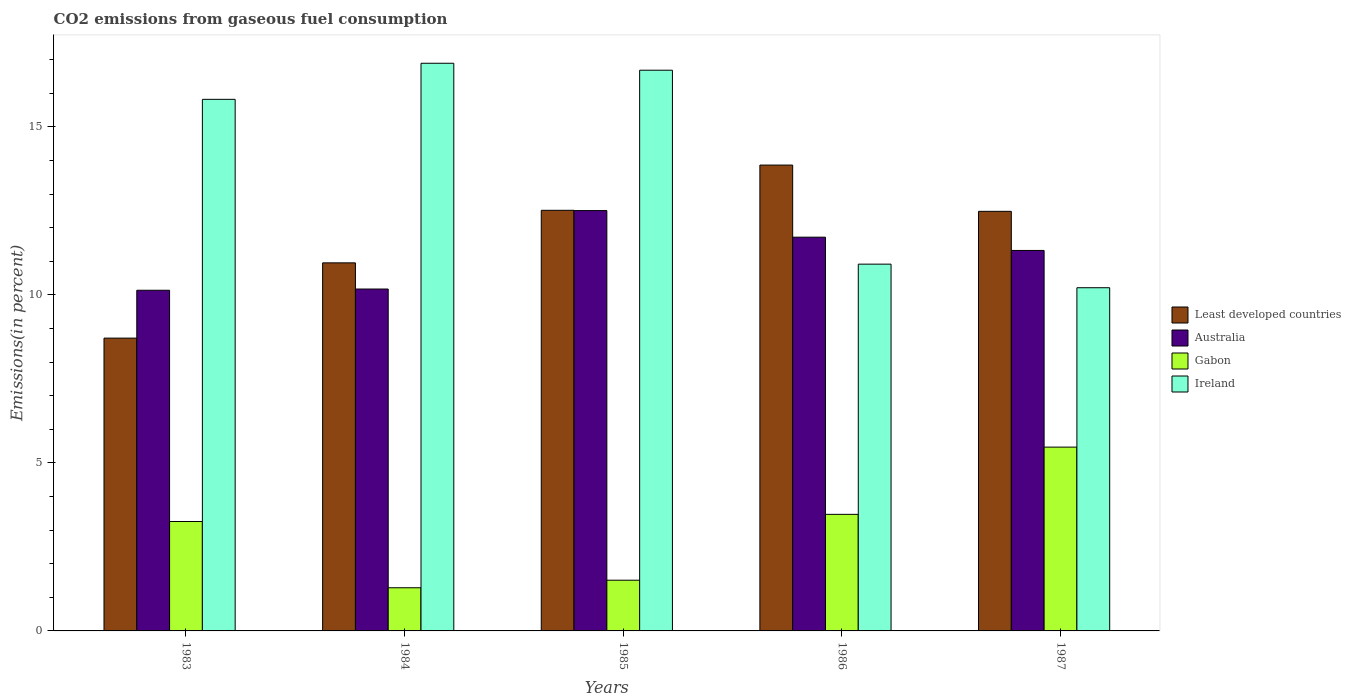How many different coloured bars are there?
Give a very brief answer. 4. Are the number of bars per tick equal to the number of legend labels?
Offer a terse response. Yes. How many bars are there on the 3rd tick from the right?
Provide a succinct answer. 4. What is the label of the 3rd group of bars from the left?
Give a very brief answer. 1985. In how many cases, is the number of bars for a given year not equal to the number of legend labels?
Make the answer very short. 0. What is the total CO2 emitted in Gabon in 1985?
Offer a very short reply. 1.51. Across all years, what is the maximum total CO2 emitted in Ireland?
Give a very brief answer. 16.89. Across all years, what is the minimum total CO2 emitted in Australia?
Keep it short and to the point. 10.14. In which year was the total CO2 emitted in Gabon minimum?
Provide a short and direct response. 1984. What is the total total CO2 emitted in Gabon in the graph?
Your answer should be very brief. 14.99. What is the difference between the total CO2 emitted in Ireland in 1983 and that in 1987?
Your answer should be compact. 5.61. What is the difference between the total CO2 emitted in Gabon in 1983 and the total CO2 emitted in Ireland in 1984?
Offer a very short reply. -13.64. What is the average total CO2 emitted in Least developed countries per year?
Your answer should be compact. 11.71. In the year 1984, what is the difference between the total CO2 emitted in Gabon and total CO2 emitted in Australia?
Your answer should be compact. -8.89. What is the ratio of the total CO2 emitted in Australia in 1983 to that in 1986?
Your response must be concise. 0.87. Is the difference between the total CO2 emitted in Gabon in 1983 and 1984 greater than the difference between the total CO2 emitted in Australia in 1983 and 1984?
Your response must be concise. Yes. What is the difference between the highest and the second highest total CO2 emitted in Gabon?
Offer a terse response. 2. What is the difference between the highest and the lowest total CO2 emitted in Least developed countries?
Give a very brief answer. 5.15. Is the sum of the total CO2 emitted in Australia in 1984 and 1985 greater than the maximum total CO2 emitted in Least developed countries across all years?
Offer a very short reply. Yes. Is it the case that in every year, the sum of the total CO2 emitted in Least developed countries and total CO2 emitted in Gabon is greater than the sum of total CO2 emitted in Australia and total CO2 emitted in Ireland?
Give a very brief answer. No. What does the 4th bar from the left in 1985 represents?
Offer a terse response. Ireland. What does the 4th bar from the right in 1984 represents?
Keep it short and to the point. Least developed countries. How many years are there in the graph?
Offer a very short reply. 5. What is the difference between two consecutive major ticks on the Y-axis?
Provide a short and direct response. 5. Are the values on the major ticks of Y-axis written in scientific E-notation?
Your response must be concise. No. Where does the legend appear in the graph?
Offer a terse response. Center right. How many legend labels are there?
Keep it short and to the point. 4. What is the title of the graph?
Your response must be concise. CO2 emissions from gaseous fuel consumption. Does "New Zealand" appear as one of the legend labels in the graph?
Offer a terse response. No. What is the label or title of the Y-axis?
Offer a terse response. Emissions(in percent). What is the Emissions(in percent) in Least developed countries in 1983?
Your response must be concise. 8.71. What is the Emissions(in percent) in Australia in 1983?
Your answer should be compact. 10.14. What is the Emissions(in percent) in Gabon in 1983?
Your response must be concise. 3.26. What is the Emissions(in percent) of Ireland in 1983?
Give a very brief answer. 15.82. What is the Emissions(in percent) of Least developed countries in 1984?
Provide a short and direct response. 10.95. What is the Emissions(in percent) in Australia in 1984?
Your answer should be very brief. 10.17. What is the Emissions(in percent) of Gabon in 1984?
Give a very brief answer. 1.28. What is the Emissions(in percent) in Ireland in 1984?
Keep it short and to the point. 16.89. What is the Emissions(in percent) of Least developed countries in 1985?
Keep it short and to the point. 12.52. What is the Emissions(in percent) in Australia in 1985?
Ensure brevity in your answer.  12.51. What is the Emissions(in percent) of Gabon in 1985?
Your answer should be compact. 1.51. What is the Emissions(in percent) of Ireland in 1985?
Your answer should be compact. 16.68. What is the Emissions(in percent) of Least developed countries in 1986?
Offer a terse response. 13.86. What is the Emissions(in percent) in Australia in 1986?
Your answer should be very brief. 11.72. What is the Emissions(in percent) in Gabon in 1986?
Provide a short and direct response. 3.47. What is the Emissions(in percent) of Ireland in 1986?
Give a very brief answer. 10.91. What is the Emissions(in percent) in Least developed countries in 1987?
Your response must be concise. 12.49. What is the Emissions(in percent) of Australia in 1987?
Provide a short and direct response. 11.32. What is the Emissions(in percent) in Gabon in 1987?
Provide a succinct answer. 5.47. What is the Emissions(in percent) in Ireland in 1987?
Provide a short and direct response. 10.21. Across all years, what is the maximum Emissions(in percent) in Least developed countries?
Provide a short and direct response. 13.86. Across all years, what is the maximum Emissions(in percent) of Australia?
Provide a succinct answer. 12.51. Across all years, what is the maximum Emissions(in percent) in Gabon?
Offer a very short reply. 5.47. Across all years, what is the maximum Emissions(in percent) of Ireland?
Provide a succinct answer. 16.89. Across all years, what is the minimum Emissions(in percent) of Least developed countries?
Provide a succinct answer. 8.71. Across all years, what is the minimum Emissions(in percent) of Australia?
Provide a short and direct response. 10.14. Across all years, what is the minimum Emissions(in percent) of Gabon?
Provide a succinct answer. 1.28. Across all years, what is the minimum Emissions(in percent) of Ireland?
Your response must be concise. 10.21. What is the total Emissions(in percent) in Least developed countries in the graph?
Ensure brevity in your answer.  58.53. What is the total Emissions(in percent) of Australia in the graph?
Keep it short and to the point. 55.86. What is the total Emissions(in percent) of Gabon in the graph?
Make the answer very short. 14.99. What is the total Emissions(in percent) of Ireland in the graph?
Offer a terse response. 70.52. What is the difference between the Emissions(in percent) of Least developed countries in 1983 and that in 1984?
Ensure brevity in your answer.  -2.24. What is the difference between the Emissions(in percent) of Australia in 1983 and that in 1984?
Provide a succinct answer. -0.04. What is the difference between the Emissions(in percent) of Gabon in 1983 and that in 1984?
Offer a terse response. 1.97. What is the difference between the Emissions(in percent) in Ireland in 1983 and that in 1984?
Offer a terse response. -1.07. What is the difference between the Emissions(in percent) in Least developed countries in 1983 and that in 1985?
Provide a succinct answer. -3.8. What is the difference between the Emissions(in percent) of Australia in 1983 and that in 1985?
Make the answer very short. -2.37. What is the difference between the Emissions(in percent) of Gabon in 1983 and that in 1985?
Your answer should be compact. 1.75. What is the difference between the Emissions(in percent) of Ireland in 1983 and that in 1985?
Provide a short and direct response. -0.87. What is the difference between the Emissions(in percent) in Least developed countries in 1983 and that in 1986?
Ensure brevity in your answer.  -5.15. What is the difference between the Emissions(in percent) in Australia in 1983 and that in 1986?
Keep it short and to the point. -1.58. What is the difference between the Emissions(in percent) in Gabon in 1983 and that in 1986?
Offer a very short reply. -0.21. What is the difference between the Emissions(in percent) of Ireland in 1983 and that in 1986?
Your answer should be compact. 4.9. What is the difference between the Emissions(in percent) of Least developed countries in 1983 and that in 1987?
Offer a very short reply. -3.77. What is the difference between the Emissions(in percent) of Australia in 1983 and that in 1987?
Offer a terse response. -1.18. What is the difference between the Emissions(in percent) in Gabon in 1983 and that in 1987?
Your answer should be very brief. -2.21. What is the difference between the Emissions(in percent) of Ireland in 1983 and that in 1987?
Offer a terse response. 5.61. What is the difference between the Emissions(in percent) of Least developed countries in 1984 and that in 1985?
Make the answer very short. -1.56. What is the difference between the Emissions(in percent) in Australia in 1984 and that in 1985?
Keep it short and to the point. -2.33. What is the difference between the Emissions(in percent) of Gabon in 1984 and that in 1985?
Provide a succinct answer. -0.22. What is the difference between the Emissions(in percent) in Ireland in 1984 and that in 1985?
Your answer should be very brief. 0.21. What is the difference between the Emissions(in percent) in Least developed countries in 1984 and that in 1986?
Your response must be concise. -2.91. What is the difference between the Emissions(in percent) in Australia in 1984 and that in 1986?
Provide a succinct answer. -1.54. What is the difference between the Emissions(in percent) in Gabon in 1984 and that in 1986?
Offer a terse response. -2.18. What is the difference between the Emissions(in percent) of Ireland in 1984 and that in 1986?
Ensure brevity in your answer.  5.98. What is the difference between the Emissions(in percent) in Least developed countries in 1984 and that in 1987?
Provide a short and direct response. -1.53. What is the difference between the Emissions(in percent) of Australia in 1984 and that in 1987?
Your response must be concise. -1.15. What is the difference between the Emissions(in percent) in Gabon in 1984 and that in 1987?
Your answer should be very brief. -4.19. What is the difference between the Emissions(in percent) in Ireland in 1984 and that in 1987?
Provide a succinct answer. 6.68. What is the difference between the Emissions(in percent) in Least developed countries in 1985 and that in 1986?
Your response must be concise. -1.35. What is the difference between the Emissions(in percent) of Australia in 1985 and that in 1986?
Provide a short and direct response. 0.79. What is the difference between the Emissions(in percent) of Gabon in 1985 and that in 1986?
Offer a terse response. -1.96. What is the difference between the Emissions(in percent) in Ireland in 1985 and that in 1986?
Make the answer very short. 5.77. What is the difference between the Emissions(in percent) of Least developed countries in 1985 and that in 1987?
Provide a short and direct response. 0.03. What is the difference between the Emissions(in percent) of Australia in 1985 and that in 1987?
Your answer should be compact. 1.19. What is the difference between the Emissions(in percent) of Gabon in 1985 and that in 1987?
Your answer should be compact. -3.96. What is the difference between the Emissions(in percent) in Ireland in 1985 and that in 1987?
Your answer should be very brief. 6.47. What is the difference between the Emissions(in percent) in Least developed countries in 1986 and that in 1987?
Your answer should be very brief. 1.38. What is the difference between the Emissions(in percent) in Australia in 1986 and that in 1987?
Your response must be concise. 0.39. What is the difference between the Emissions(in percent) in Gabon in 1986 and that in 1987?
Give a very brief answer. -2. What is the difference between the Emissions(in percent) of Ireland in 1986 and that in 1987?
Your response must be concise. 0.7. What is the difference between the Emissions(in percent) of Least developed countries in 1983 and the Emissions(in percent) of Australia in 1984?
Make the answer very short. -1.46. What is the difference between the Emissions(in percent) of Least developed countries in 1983 and the Emissions(in percent) of Gabon in 1984?
Provide a succinct answer. 7.43. What is the difference between the Emissions(in percent) in Least developed countries in 1983 and the Emissions(in percent) in Ireland in 1984?
Give a very brief answer. -8.18. What is the difference between the Emissions(in percent) in Australia in 1983 and the Emissions(in percent) in Gabon in 1984?
Your response must be concise. 8.85. What is the difference between the Emissions(in percent) of Australia in 1983 and the Emissions(in percent) of Ireland in 1984?
Offer a very short reply. -6.75. What is the difference between the Emissions(in percent) in Gabon in 1983 and the Emissions(in percent) in Ireland in 1984?
Keep it short and to the point. -13.64. What is the difference between the Emissions(in percent) in Least developed countries in 1983 and the Emissions(in percent) in Australia in 1985?
Give a very brief answer. -3.79. What is the difference between the Emissions(in percent) in Least developed countries in 1983 and the Emissions(in percent) in Gabon in 1985?
Ensure brevity in your answer.  7.2. What is the difference between the Emissions(in percent) in Least developed countries in 1983 and the Emissions(in percent) in Ireland in 1985?
Provide a short and direct response. -7.97. What is the difference between the Emissions(in percent) of Australia in 1983 and the Emissions(in percent) of Gabon in 1985?
Your answer should be very brief. 8.63. What is the difference between the Emissions(in percent) of Australia in 1983 and the Emissions(in percent) of Ireland in 1985?
Give a very brief answer. -6.55. What is the difference between the Emissions(in percent) of Gabon in 1983 and the Emissions(in percent) of Ireland in 1985?
Ensure brevity in your answer.  -13.43. What is the difference between the Emissions(in percent) in Least developed countries in 1983 and the Emissions(in percent) in Australia in 1986?
Offer a very short reply. -3. What is the difference between the Emissions(in percent) of Least developed countries in 1983 and the Emissions(in percent) of Gabon in 1986?
Keep it short and to the point. 5.24. What is the difference between the Emissions(in percent) of Least developed countries in 1983 and the Emissions(in percent) of Ireland in 1986?
Your answer should be very brief. -2.2. What is the difference between the Emissions(in percent) of Australia in 1983 and the Emissions(in percent) of Gabon in 1986?
Offer a terse response. 6.67. What is the difference between the Emissions(in percent) in Australia in 1983 and the Emissions(in percent) in Ireland in 1986?
Make the answer very short. -0.78. What is the difference between the Emissions(in percent) of Gabon in 1983 and the Emissions(in percent) of Ireland in 1986?
Your answer should be very brief. -7.66. What is the difference between the Emissions(in percent) of Least developed countries in 1983 and the Emissions(in percent) of Australia in 1987?
Make the answer very short. -2.61. What is the difference between the Emissions(in percent) in Least developed countries in 1983 and the Emissions(in percent) in Gabon in 1987?
Ensure brevity in your answer.  3.24. What is the difference between the Emissions(in percent) of Least developed countries in 1983 and the Emissions(in percent) of Ireland in 1987?
Provide a succinct answer. -1.5. What is the difference between the Emissions(in percent) in Australia in 1983 and the Emissions(in percent) in Gabon in 1987?
Give a very brief answer. 4.67. What is the difference between the Emissions(in percent) of Australia in 1983 and the Emissions(in percent) of Ireland in 1987?
Your answer should be compact. -0.08. What is the difference between the Emissions(in percent) in Gabon in 1983 and the Emissions(in percent) in Ireland in 1987?
Provide a short and direct response. -6.96. What is the difference between the Emissions(in percent) of Least developed countries in 1984 and the Emissions(in percent) of Australia in 1985?
Your answer should be compact. -1.56. What is the difference between the Emissions(in percent) in Least developed countries in 1984 and the Emissions(in percent) in Gabon in 1985?
Give a very brief answer. 9.44. What is the difference between the Emissions(in percent) of Least developed countries in 1984 and the Emissions(in percent) of Ireland in 1985?
Keep it short and to the point. -5.73. What is the difference between the Emissions(in percent) of Australia in 1984 and the Emissions(in percent) of Gabon in 1985?
Your answer should be compact. 8.66. What is the difference between the Emissions(in percent) in Australia in 1984 and the Emissions(in percent) in Ireland in 1985?
Your answer should be compact. -6.51. What is the difference between the Emissions(in percent) in Gabon in 1984 and the Emissions(in percent) in Ireland in 1985?
Provide a succinct answer. -15.4. What is the difference between the Emissions(in percent) in Least developed countries in 1984 and the Emissions(in percent) in Australia in 1986?
Ensure brevity in your answer.  -0.76. What is the difference between the Emissions(in percent) of Least developed countries in 1984 and the Emissions(in percent) of Gabon in 1986?
Offer a very short reply. 7.48. What is the difference between the Emissions(in percent) of Least developed countries in 1984 and the Emissions(in percent) of Ireland in 1986?
Provide a short and direct response. 0.04. What is the difference between the Emissions(in percent) in Australia in 1984 and the Emissions(in percent) in Gabon in 1986?
Your response must be concise. 6.71. What is the difference between the Emissions(in percent) of Australia in 1984 and the Emissions(in percent) of Ireland in 1986?
Offer a very short reply. -0.74. What is the difference between the Emissions(in percent) of Gabon in 1984 and the Emissions(in percent) of Ireland in 1986?
Your response must be concise. -9.63. What is the difference between the Emissions(in percent) in Least developed countries in 1984 and the Emissions(in percent) in Australia in 1987?
Make the answer very short. -0.37. What is the difference between the Emissions(in percent) of Least developed countries in 1984 and the Emissions(in percent) of Gabon in 1987?
Keep it short and to the point. 5.48. What is the difference between the Emissions(in percent) of Least developed countries in 1984 and the Emissions(in percent) of Ireland in 1987?
Offer a very short reply. 0.74. What is the difference between the Emissions(in percent) in Australia in 1984 and the Emissions(in percent) in Gabon in 1987?
Offer a very short reply. 4.7. What is the difference between the Emissions(in percent) in Australia in 1984 and the Emissions(in percent) in Ireland in 1987?
Offer a very short reply. -0.04. What is the difference between the Emissions(in percent) of Gabon in 1984 and the Emissions(in percent) of Ireland in 1987?
Give a very brief answer. -8.93. What is the difference between the Emissions(in percent) in Least developed countries in 1985 and the Emissions(in percent) in Australia in 1986?
Give a very brief answer. 0.8. What is the difference between the Emissions(in percent) of Least developed countries in 1985 and the Emissions(in percent) of Gabon in 1986?
Your answer should be very brief. 9.05. What is the difference between the Emissions(in percent) of Least developed countries in 1985 and the Emissions(in percent) of Ireland in 1986?
Offer a terse response. 1.6. What is the difference between the Emissions(in percent) in Australia in 1985 and the Emissions(in percent) in Gabon in 1986?
Give a very brief answer. 9.04. What is the difference between the Emissions(in percent) of Australia in 1985 and the Emissions(in percent) of Ireland in 1986?
Your answer should be very brief. 1.59. What is the difference between the Emissions(in percent) of Gabon in 1985 and the Emissions(in percent) of Ireland in 1986?
Ensure brevity in your answer.  -9.4. What is the difference between the Emissions(in percent) of Least developed countries in 1985 and the Emissions(in percent) of Australia in 1987?
Your answer should be compact. 1.19. What is the difference between the Emissions(in percent) in Least developed countries in 1985 and the Emissions(in percent) in Gabon in 1987?
Give a very brief answer. 7.05. What is the difference between the Emissions(in percent) in Least developed countries in 1985 and the Emissions(in percent) in Ireland in 1987?
Ensure brevity in your answer.  2.3. What is the difference between the Emissions(in percent) of Australia in 1985 and the Emissions(in percent) of Gabon in 1987?
Provide a short and direct response. 7.04. What is the difference between the Emissions(in percent) in Australia in 1985 and the Emissions(in percent) in Ireland in 1987?
Your answer should be very brief. 2.3. What is the difference between the Emissions(in percent) in Gabon in 1985 and the Emissions(in percent) in Ireland in 1987?
Your answer should be very brief. -8.7. What is the difference between the Emissions(in percent) in Least developed countries in 1986 and the Emissions(in percent) in Australia in 1987?
Ensure brevity in your answer.  2.54. What is the difference between the Emissions(in percent) in Least developed countries in 1986 and the Emissions(in percent) in Gabon in 1987?
Your response must be concise. 8.39. What is the difference between the Emissions(in percent) in Least developed countries in 1986 and the Emissions(in percent) in Ireland in 1987?
Offer a very short reply. 3.65. What is the difference between the Emissions(in percent) in Australia in 1986 and the Emissions(in percent) in Gabon in 1987?
Offer a very short reply. 6.25. What is the difference between the Emissions(in percent) in Australia in 1986 and the Emissions(in percent) in Ireland in 1987?
Provide a succinct answer. 1.5. What is the difference between the Emissions(in percent) in Gabon in 1986 and the Emissions(in percent) in Ireland in 1987?
Your answer should be compact. -6.74. What is the average Emissions(in percent) of Least developed countries per year?
Offer a very short reply. 11.71. What is the average Emissions(in percent) in Australia per year?
Ensure brevity in your answer.  11.17. What is the average Emissions(in percent) of Gabon per year?
Offer a terse response. 3. What is the average Emissions(in percent) in Ireland per year?
Your answer should be compact. 14.1. In the year 1983, what is the difference between the Emissions(in percent) in Least developed countries and Emissions(in percent) in Australia?
Provide a short and direct response. -1.42. In the year 1983, what is the difference between the Emissions(in percent) of Least developed countries and Emissions(in percent) of Gabon?
Ensure brevity in your answer.  5.46. In the year 1983, what is the difference between the Emissions(in percent) in Least developed countries and Emissions(in percent) in Ireland?
Make the answer very short. -7.11. In the year 1983, what is the difference between the Emissions(in percent) in Australia and Emissions(in percent) in Gabon?
Offer a very short reply. 6.88. In the year 1983, what is the difference between the Emissions(in percent) in Australia and Emissions(in percent) in Ireland?
Offer a terse response. -5.68. In the year 1983, what is the difference between the Emissions(in percent) of Gabon and Emissions(in percent) of Ireland?
Your answer should be compact. -12.56. In the year 1984, what is the difference between the Emissions(in percent) of Least developed countries and Emissions(in percent) of Australia?
Keep it short and to the point. 0.78. In the year 1984, what is the difference between the Emissions(in percent) in Least developed countries and Emissions(in percent) in Gabon?
Your answer should be very brief. 9.67. In the year 1984, what is the difference between the Emissions(in percent) in Least developed countries and Emissions(in percent) in Ireland?
Provide a succinct answer. -5.94. In the year 1984, what is the difference between the Emissions(in percent) of Australia and Emissions(in percent) of Gabon?
Provide a succinct answer. 8.89. In the year 1984, what is the difference between the Emissions(in percent) in Australia and Emissions(in percent) in Ireland?
Offer a very short reply. -6.72. In the year 1984, what is the difference between the Emissions(in percent) in Gabon and Emissions(in percent) in Ireland?
Offer a very short reply. -15.61. In the year 1985, what is the difference between the Emissions(in percent) in Least developed countries and Emissions(in percent) in Australia?
Keep it short and to the point. 0.01. In the year 1985, what is the difference between the Emissions(in percent) of Least developed countries and Emissions(in percent) of Gabon?
Provide a succinct answer. 11.01. In the year 1985, what is the difference between the Emissions(in percent) of Least developed countries and Emissions(in percent) of Ireland?
Provide a short and direct response. -4.17. In the year 1985, what is the difference between the Emissions(in percent) of Australia and Emissions(in percent) of Gabon?
Provide a succinct answer. 11. In the year 1985, what is the difference between the Emissions(in percent) in Australia and Emissions(in percent) in Ireland?
Provide a short and direct response. -4.18. In the year 1985, what is the difference between the Emissions(in percent) in Gabon and Emissions(in percent) in Ireland?
Provide a succinct answer. -15.18. In the year 1986, what is the difference between the Emissions(in percent) of Least developed countries and Emissions(in percent) of Australia?
Provide a succinct answer. 2.15. In the year 1986, what is the difference between the Emissions(in percent) in Least developed countries and Emissions(in percent) in Gabon?
Provide a short and direct response. 10.39. In the year 1986, what is the difference between the Emissions(in percent) in Least developed countries and Emissions(in percent) in Ireland?
Give a very brief answer. 2.95. In the year 1986, what is the difference between the Emissions(in percent) of Australia and Emissions(in percent) of Gabon?
Your response must be concise. 8.25. In the year 1986, what is the difference between the Emissions(in percent) in Australia and Emissions(in percent) in Ireland?
Provide a succinct answer. 0.8. In the year 1986, what is the difference between the Emissions(in percent) of Gabon and Emissions(in percent) of Ireland?
Offer a terse response. -7.45. In the year 1987, what is the difference between the Emissions(in percent) in Least developed countries and Emissions(in percent) in Australia?
Provide a succinct answer. 1.16. In the year 1987, what is the difference between the Emissions(in percent) in Least developed countries and Emissions(in percent) in Gabon?
Provide a short and direct response. 7.02. In the year 1987, what is the difference between the Emissions(in percent) of Least developed countries and Emissions(in percent) of Ireland?
Give a very brief answer. 2.27. In the year 1987, what is the difference between the Emissions(in percent) of Australia and Emissions(in percent) of Gabon?
Keep it short and to the point. 5.85. In the year 1987, what is the difference between the Emissions(in percent) of Australia and Emissions(in percent) of Ireland?
Provide a short and direct response. 1.11. In the year 1987, what is the difference between the Emissions(in percent) in Gabon and Emissions(in percent) in Ireland?
Offer a terse response. -4.74. What is the ratio of the Emissions(in percent) of Least developed countries in 1983 to that in 1984?
Offer a very short reply. 0.8. What is the ratio of the Emissions(in percent) in Australia in 1983 to that in 1984?
Provide a short and direct response. 1. What is the ratio of the Emissions(in percent) in Gabon in 1983 to that in 1984?
Give a very brief answer. 2.53. What is the ratio of the Emissions(in percent) of Ireland in 1983 to that in 1984?
Give a very brief answer. 0.94. What is the ratio of the Emissions(in percent) in Least developed countries in 1983 to that in 1985?
Offer a terse response. 0.7. What is the ratio of the Emissions(in percent) of Australia in 1983 to that in 1985?
Your answer should be very brief. 0.81. What is the ratio of the Emissions(in percent) of Gabon in 1983 to that in 1985?
Provide a succinct answer. 2.16. What is the ratio of the Emissions(in percent) in Ireland in 1983 to that in 1985?
Give a very brief answer. 0.95. What is the ratio of the Emissions(in percent) of Least developed countries in 1983 to that in 1986?
Keep it short and to the point. 0.63. What is the ratio of the Emissions(in percent) of Australia in 1983 to that in 1986?
Your response must be concise. 0.87. What is the ratio of the Emissions(in percent) of Gabon in 1983 to that in 1986?
Keep it short and to the point. 0.94. What is the ratio of the Emissions(in percent) of Ireland in 1983 to that in 1986?
Give a very brief answer. 1.45. What is the ratio of the Emissions(in percent) of Least developed countries in 1983 to that in 1987?
Offer a terse response. 0.7. What is the ratio of the Emissions(in percent) of Australia in 1983 to that in 1987?
Provide a short and direct response. 0.9. What is the ratio of the Emissions(in percent) of Gabon in 1983 to that in 1987?
Offer a very short reply. 0.6. What is the ratio of the Emissions(in percent) of Ireland in 1983 to that in 1987?
Offer a terse response. 1.55. What is the ratio of the Emissions(in percent) in Least developed countries in 1984 to that in 1985?
Make the answer very short. 0.88. What is the ratio of the Emissions(in percent) of Australia in 1984 to that in 1985?
Offer a very short reply. 0.81. What is the ratio of the Emissions(in percent) of Gabon in 1984 to that in 1985?
Keep it short and to the point. 0.85. What is the ratio of the Emissions(in percent) in Ireland in 1984 to that in 1985?
Your response must be concise. 1.01. What is the ratio of the Emissions(in percent) of Least developed countries in 1984 to that in 1986?
Provide a short and direct response. 0.79. What is the ratio of the Emissions(in percent) of Australia in 1984 to that in 1986?
Provide a succinct answer. 0.87. What is the ratio of the Emissions(in percent) in Gabon in 1984 to that in 1986?
Your answer should be compact. 0.37. What is the ratio of the Emissions(in percent) in Ireland in 1984 to that in 1986?
Keep it short and to the point. 1.55. What is the ratio of the Emissions(in percent) of Least developed countries in 1984 to that in 1987?
Make the answer very short. 0.88. What is the ratio of the Emissions(in percent) of Australia in 1984 to that in 1987?
Your answer should be compact. 0.9. What is the ratio of the Emissions(in percent) in Gabon in 1984 to that in 1987?
Make the answer very short. 0.23. What is the ratio of the Emissions(in percent) of Ireland in 1984 to that in 1987?
Make the answer very short. 1.65. What is the ratio of the Emissions(in percent) of Least developed countries in 1985 to that in 1986?
Your answer should be compact. 0.9. What is the ratio of the Emissions(in percent) of Australia in 1985 to that in 1986?
Offer a terse response. 1.07. What is the ratio of the Emissions(in percent) of Gabon in 1985 to that in 1986?
Keep it short and to the point. 0.43. What is the ratio of the Emissions(in percent) of Ireland in 1985 to that in 1986?
Ensure brevity in your answer.  1.53. What is the ratio of the Emissions(in percent) in Least developed countries in 1985 to that in 1987?
Offer a very short reply. 1. What is the ratio of the Emissions(in percent) in Australia in 1985 to that in 1987?
Offer a terse response. 1.1. What is the ratio of the Emissions(in percent) of Gabon in 1985 to that in 1987?
Keep it short and to the point. 0.28. What is the ratio of the Emissions(in percent) of Ireland in 1985 to that in 1987?
Offer a terse response. 1.63. What is the ratio of the Emissions(in percent) of Least developed countries in 1986 to that in 1987?
Your response must be concise. 1.11. What is the ratio of the Emissions(in percent) of Australia in 1986 to that in 1987?
Your answer should be very brief. 1.03. What is the ratio of the Emissions(in percent) in Gabon in 1986 to that in 1987?
Your answer should be very brief. 0.63. What is the ratio of the Emissions(in percent) in Ireland in 1986 to that in 1987?
Your answer should be compact. 1.07. What is the difference between the highest and the second highest Emissions(in percent) of Least developed countries?
Keep it short and to the point. 1.35. What is the difference between the highest and the second highest Emissions(in percent) of Australia?
Offer a very short reply. 0.79. What is the difference between the highest and the second highest Emissions(in percent) of Gabon?
Offer a terse response. 2. What is the difference between the highest and the second highest Emissions(in percent) in Ireland?
Provide a short and direct response. 0.21. What is the difference between the highest and the lowest Emissions(in percent) in Least developed countries?
Provide a succinct answer. 5.15. What is the difference between the highest and the lowest Emissions(in percent) of Australia?
Give a very brief answer. 2.37. What is the difference between the highest and the lowest Emissions(in percent) of Gabon?
Offer a very short reply. 4.19. What is the difference between the highest and the lowest Emissions(in percent) of Ireland?
Ensure brevity in your answer.  6.68. 